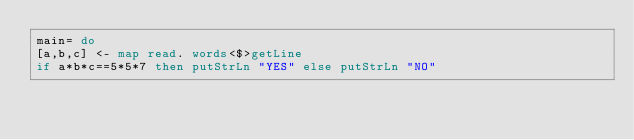<code> <loc_0><loc_0><loc_500><loc_500><_Haskell_>main= do
[a,b,c] <- map read. words<$>getLine
if a*b*c==5*5*7 then putStrLn "YES" else putStrLn "NO"</code> 